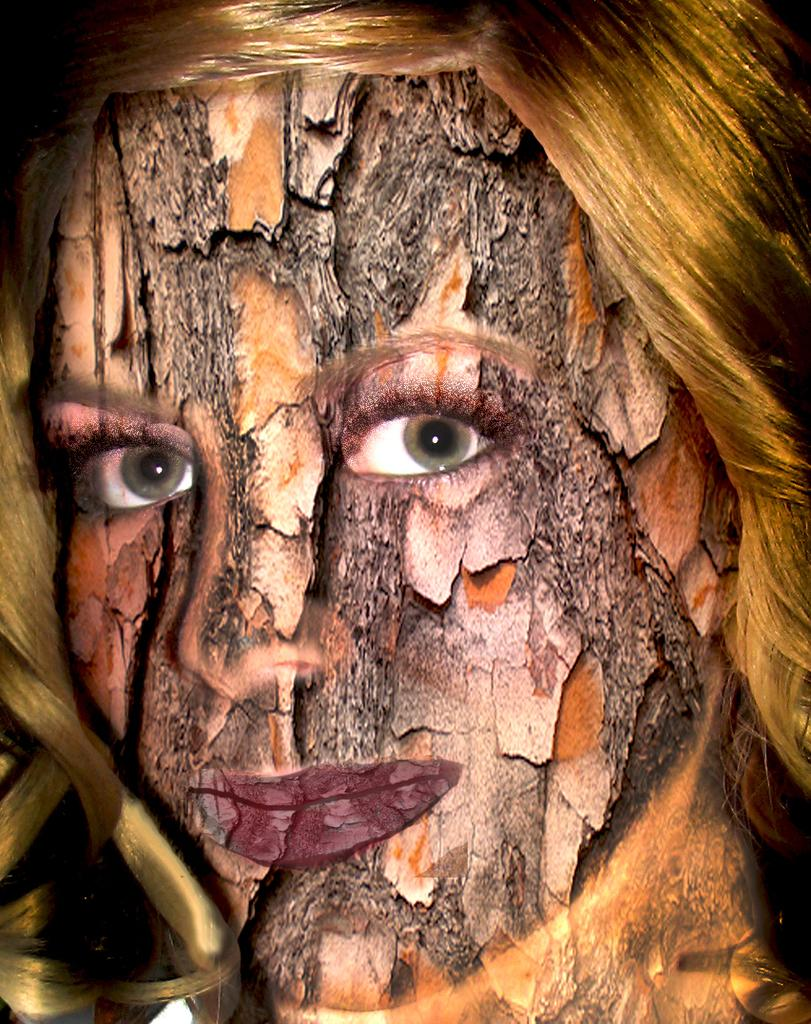What can be observed about the image's appearance? The image is edited. Who is present in the image? There is a woman in the image. What type of waste is being disposed of in the image? There is no waste present in the image; it only features a woman. What selection of items can be seen in the image? The image only contains a woman, so there is no selection of items to discuss. 